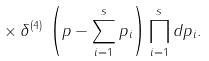<formula> <loc_0><loc_0><loc_500><loc_500>\times \, { \delta } ^ { ( 4 ) } \, \left ( p - \sum _ { i = 1 } ^ { s } p _ { i } \right ) \prod _ { i = 1 } ^ { s } d p _ { i } .</formula> 